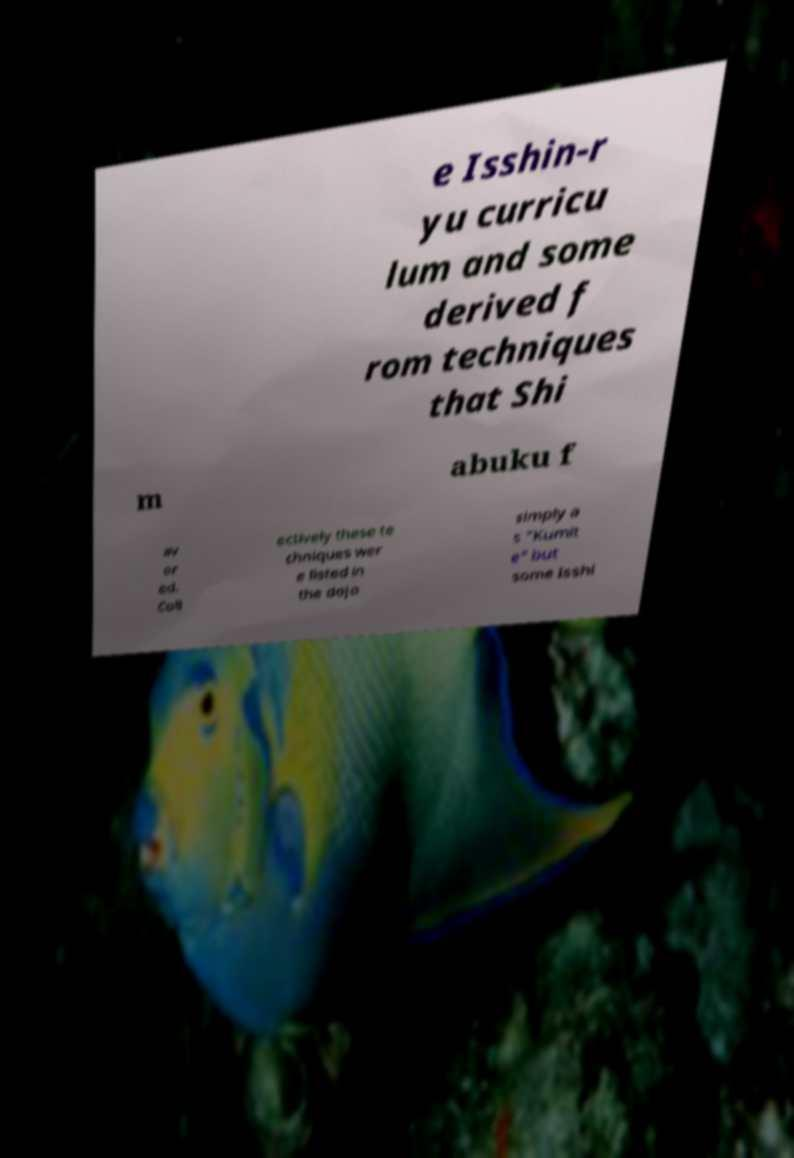Can you accurately transcribe the text from the provided image for me? e Isshin-r yu curricu lum and some derived f rom techniques that Shi m abuku f av or ed. Coll ectively these te chniques wer e listed in the dojo simply a s "Kumit e" but some Isshi 